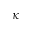Convert formula to latex. <formula><loc_0><loc_0><loc_500><loc_500>\kappa</formula> 